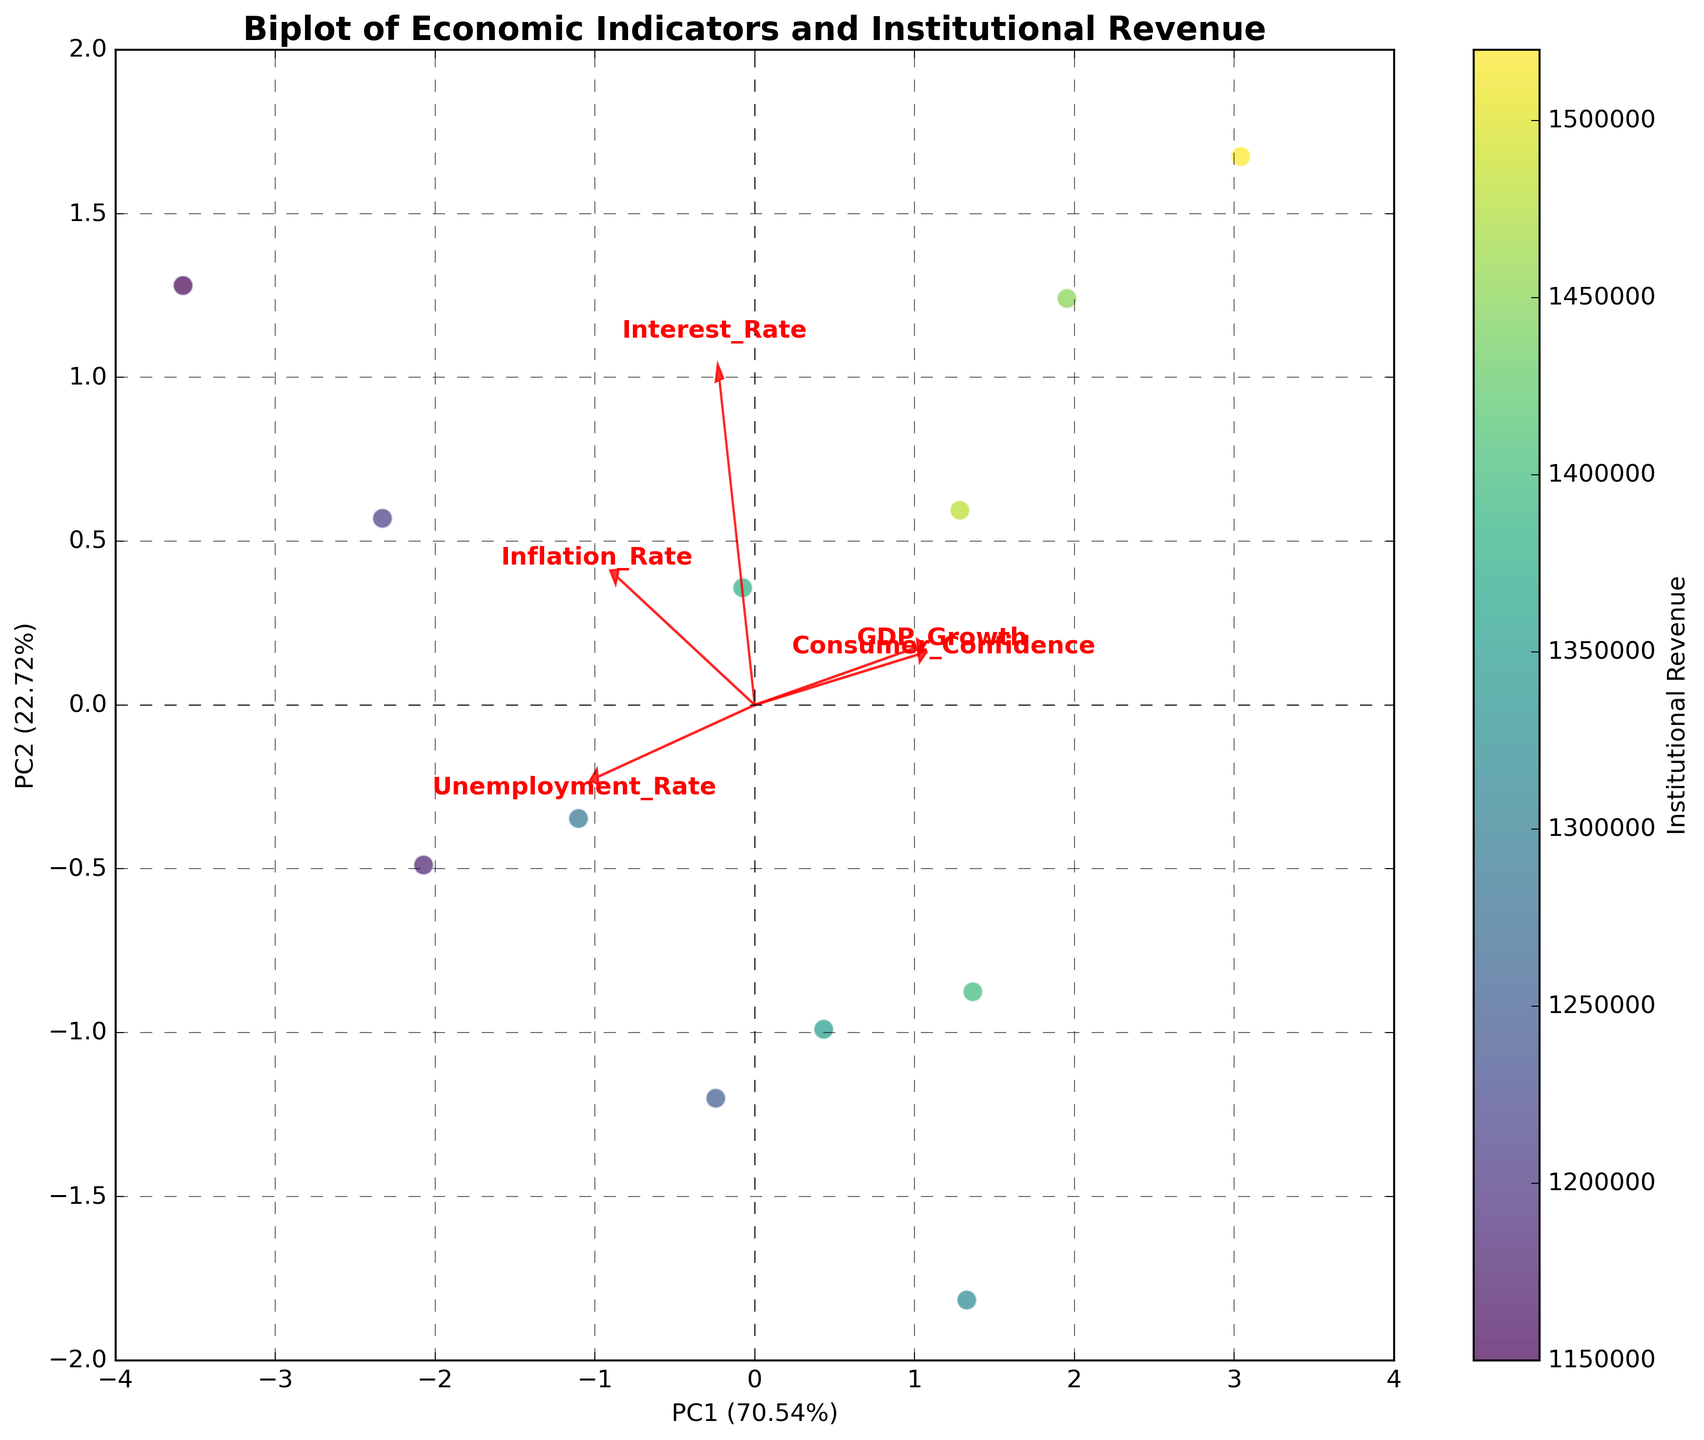What's the title of the plot? The title is displayed at the top of the figure. It reads "Biplot of Economic Indicators and Institutional Revenue."
Answer: Biplot of Economic Indicators and Institutional Revenue How many principal components (PCs) are displayed on the axes? The X and Y axes are labeled with PC1 and PC2, indicating that the biplot shows the first two principal components.
Answer: 2 What percentage of the variance is explained by PC1? The X axis label reads "PC1" followed by the percentage of variance explained in brackets. The label states "PC1 (X.XX%)". We see this percentage directly on the plot.
Answer: Percentage from the axis label Which economic indicators have the longest vectors on the plot? The length of the vectors representing economic indicators can be observed directly. Longer vectors indicate stronger contributions to the principal components.
Answer: GDP Growth and Consumer Confidence Is there a positive correlation between PC1 and Institutional Revenue? Points on the X axis are colored based on Institutional Revenue. By observing this color gradient, we detect a positive correlation if Institutional Revenue increases as PC1 increases.
Answer: Yes How does the Interest Rate vector align with respect to PC1? The direction of the Interest Rate vector can be observed relative to the PC1 axis. Positive or negative alignment indicates the direction.
Answer: Aligns positively with PC1 Which principal component does Inflation Rate contribute more strongly to? We observe the length and direction of the Inflation Rate vector. If the vector expands more in the direction of one of the principal component axes (PC1 or PC2), it contributes more to that principal component.
Answer: PC2 How do Consumer Confidence and Unemployment Rate influence the institutional revenue, based on their vectors' directions? The directions of these vectors relative to the Institutional Revenue color gradient indicate their influence. Consumer Confidence aligns positively with Institutional Revenue, while Unemployment Rate may align negatively if pointing in opposite directions.
Answer: Consumer Confidence positively, Unemployment Rate negatively What is the relationship between GDP Growth and Inflation Rate in this biplot? The angle between the vectors can be analyzed. A smaller angle between GDP Growth and Inflation Rate vectors indicates a positive relationship. A larger or close to 180-degree angle suggests a negative relationship.
Answer: Positive relationship Which vector shows the largest difference in its component contributions on PC1 and PC2? By comparing the relative lengths and directions of vectors along PC1 and PC2, the vector with the most unequal contributions (longer in one direction and shorter in another) indicates the largest difference.
Answer: Interest Rate 